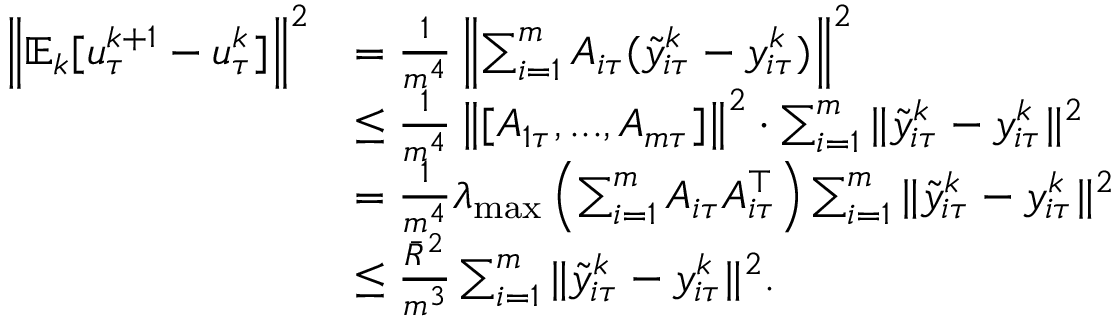Convert formula to latex. <formula><loc_0><loc_0><loc_500><loc_500>\begin{array} { r l } { \left \| \mathbb { E } _ { k } [ u _ { \tau } ^ { k + 1 } - u _ { \tau } ^ { k } ] \right \| ^ { 2 } } & { = \frac { 1 } { m ^ { 4 } } \left \| \sum _ { i = 1 } ^ { m } A _ { i \tau } ( { \tilde { y } } _ { i \tau } ^ { k } - y _ { i \tau } ^ { k } ) \right \| ^ { 2 } } \\ & { \leq \frac { 1 } { m ^ { 4 } } \left \| [ A _ { 1 \tau } , \dots , A _ { m \tau } ] \right \| ^ { 2 } \cdot \sum _ { i = 1 } ^ { m } \| { \tilde { y } } _ { i \tau } ^ { k } - y _ { i \tau } ^ { k } \| ^ { 2 } } \\ & { = \frac { 1 } { m ^ { 4 } } \lambda _ { \max } \left ( \sum _ { i = 1 } ^ { m } A _ { i \tau } A _ { i \tau } ^ { \top } \right ) \sum _ { i = 1 } ^ { m } \| { \tilde { y } } _ { i \tau } ^ { k } - y _ { i \tau } ^ { k } \| ^ { 2 } } \\ & { \leq \frac { { \bar { R } } ^ { 2 } } { m ^ { 3 } } \sum _ { i = 1 } ^ { m } \| { \tilde { y } } _ { i \tau } ^ { k } - y _ { i \tau } ^ { k } \| ^ { 2 } . } \end{array}</formula> 